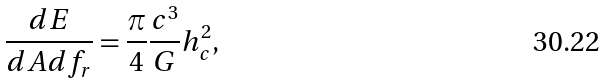<formula> <loc_0><loc_0><loc_500><loc_500>\frac { d E } { d A d f _ { r } } = \frac { \pi } { 4 } \frac { c ^ { 3 } } { G } h _ { c } ^ { 2 } ,</formula> 